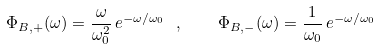Convert formula to latex. <formula><loc_0><loc_0><loc_500><loc_500>\Phi _ { B , + } ( \omega ) = \frac { \omega } { \omega _ { 0 } ^ { 2 } } \, e ^ { - \omega / \omega _ { 0 } } \ , \quad \Phi _ { B , - } ( \omega ) = \frac { 1 } { \omega _ { 0 } } \, e ^ { - \omega / \omega _ { 0 } }</formula> 